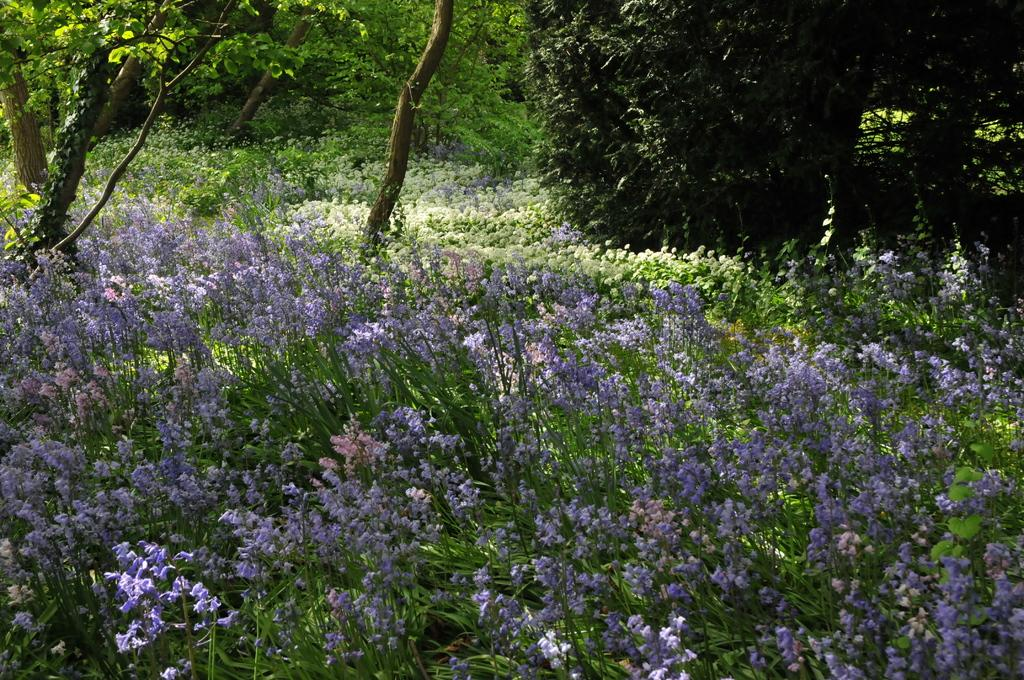What type of flora can be seen in the image? There are flowers and plants in the image. What type of vegetation is visible in the background of the image? There are trees visible in the background of the image. How many kittens are playing with a collar near the oven in the image? There are no kittens or ovens present in the image. 